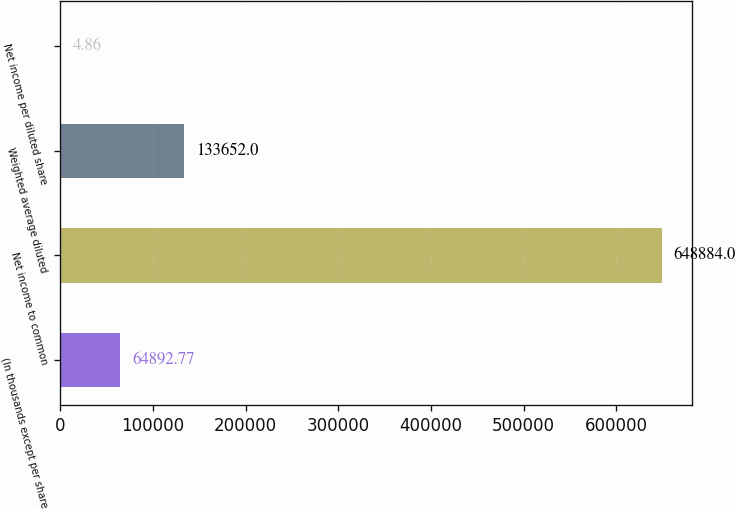Convert chart. <chart><loc_0><loc_0><loc_500><loc_500><bar_chart><fcel>(In thousands except per share<fcel>Net income to common<fcel>Weighted average diluted<fcel>Net income per diluted share<nl><fcel>64892.8<fcel>648884<fcel>133652<fcel>4.86<nl></chart> 